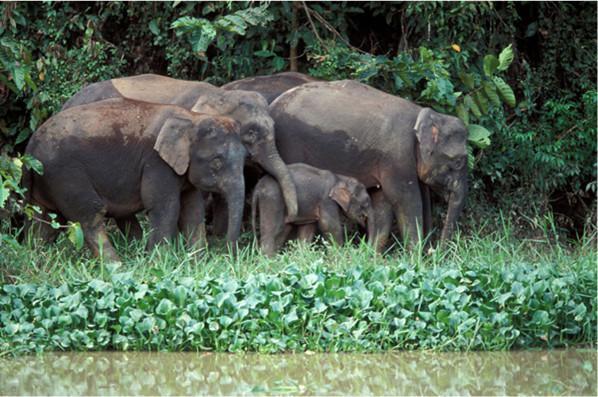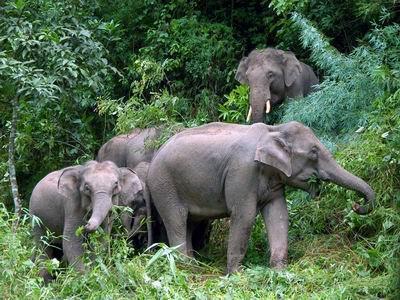The first image is the image on the left, the second image is the image on the right. Considering the images on both sides, is "There are elephants near a body of water." valid? Answer yes or no. Yes. 